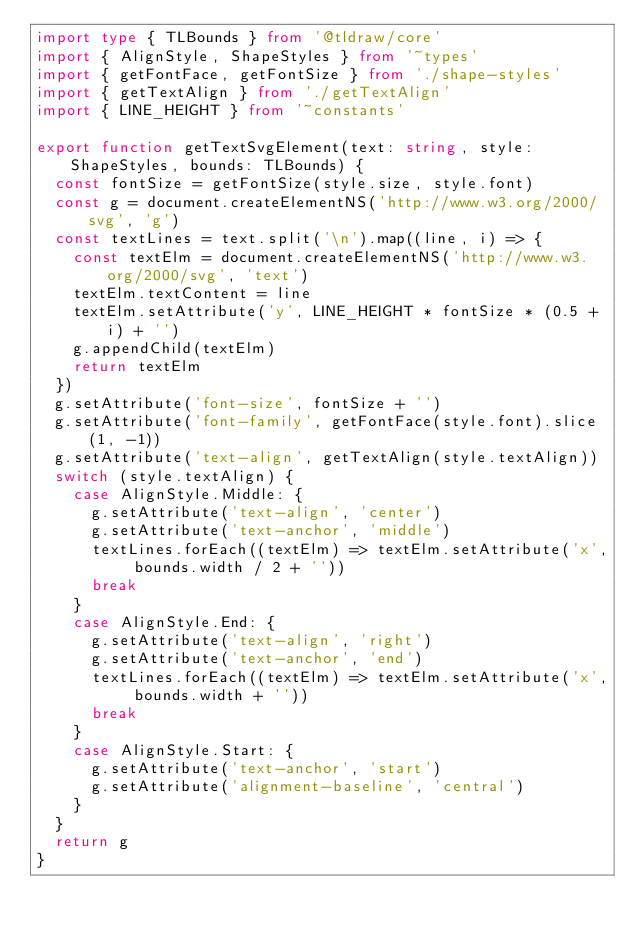<code> <loc_0><loc_0><loc_500><loc_500><_TypeScript_>import type { TLBounds } from '@tldraw/core'
import { AlignStyle, ShapeStyles } from '~types'
import { getFontFace, getFontSize } from './shape-styles'
import { getTextAlign } from './getTextAlign'
import { LINE_HEIGHT } from '~constants'

export function getTextSvgElement(text: string, style: ShapeStyles, bounds: TLBounds) {
  const fontSize = getFontSize(style.size, style.font)
  const g = document.createElementNS('http://www.w3.org/2000/svg', 'g')
  const textLines = text.split('\n').map((line, i) => {
    const textElm = document.createElementNS('http://www.w3.org/2000/svg', 'text')
    textElm.textContent = line
    textElm.setAttribute('y', LINE_HEIGHT * fontSize * (0.5 + i) + '')
    g.appendChild(textElm)
    return textElm
  })
  g.setAttribute('font-size', fontSize + '')
  g.setAttribute('font-family', getFontFace(style.font).slice(1, -1))
  g.setAttribute('text-align', getTextAlign(style.textAlign))
  switch (style.textAlign) {
    case AlignStyle.Middle: {
      g.setAttribute('text-align', 'center')
      g.setAttribute('text-anchor', 'middle')
      textLines.forEach((textElm) => textElm.setAttribute('x', bounds.width / 2 + ''))
      break
    }
    case AlignStyle.End: {
      g.setAttribute('text-align', 'right')
      g.setAttribute('text-anchor', 'end')
      textLines.forEach((textElm) => textElm.setAttribute('x', bounds.width + ''))
      break
    }
    case AlignStyle.Start: {
      g.setAttribute('text-anchor', 'start')
      g.setAttribute('alignment-baseline', 'central')
    }
  }
  return g
}
</code> 